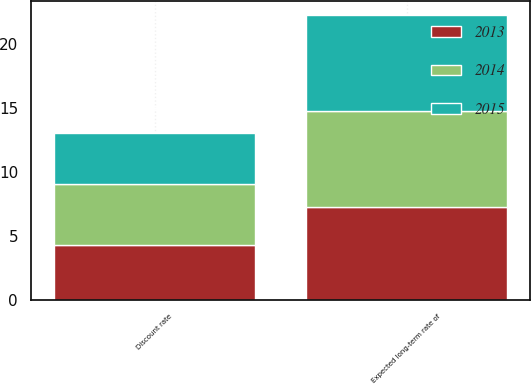<chart> <loc_0><loc_0><loc_500><loc_500><stacked_bar_chart><ecel><fcel>Discount rate<fcel>Expected long-term rate of<nl><fcel>2013<fcel>4.27<fcel>7.25<nl><fcel>2015<fcel>4<fcel>7.5<nl><fcel>2014<fcel>4.75<fcel>7.5<nl></chart> 